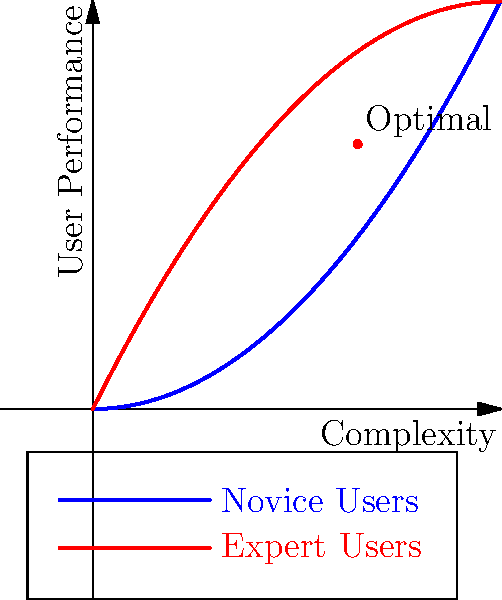Based on the topological representation of user performance versus interface complexity for robotic control systems, what can be inferred about the optimal design approach for different user groups? To answer this question, let's analyze the graph step-by-step:

1. The x-axis represents the complexity of the robotic control interface, while the y-axis represents user performance.

2. There are two curves on the graph:
   - Blue curve (parabola opening upwards): represents novice users
   - Red curve (inverted parabola): represents expert users

3. For novice users (blue curve):
   - As complexity increases, performance initially decreases
   - After a certain point, performance starts to improve with increased complexity
   - This suggests that novice users struggle with initial complexity but can benefit from more advanced features once they overcome the learning curve

4. For expert users (red curve):
   - Performance increases rapidly with initial complexity
   - Reaches a peak at moderate complexity
   - Performance decreases with further increases in complexity
   - This indicates that expert users benefit from advanced features but may be hindered by overly complex interfaces

5. The optimal point is marked on the graph, showing a balance between complexity and performance for both user groups

6. The intersection of the two curves represents the point where novice and expert users have equal performance, which occurs at a relatively low complexity level

Given this analysis, we can infer that the optimal design approach should:

a) Provide a scalable interface that can adapt to user expertise
b) Offer a basic mode with low complexity for novices
c) Include advanced features that can be progressively introduced
d) Avoid excessive complexity that may hinder expert performance
e) Aim for a balance that maximizes performance for both user groups
Answer: Adaptive, scalable interface with progressive complexity 